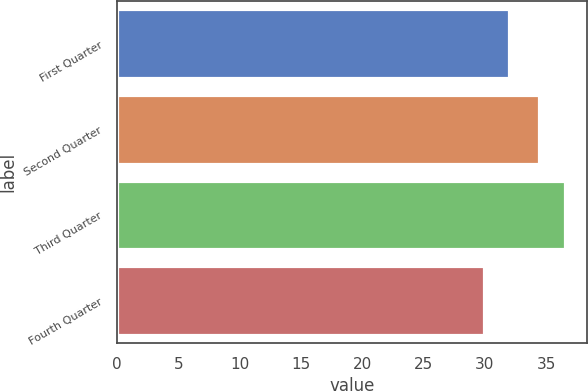<chart> <loc_0><loc_0><loc_500><loc_500><bar_chart><fcel>First Quarter<fcel>Second Quarter<fcel>Third Quarter<fcel>Fourth Quarter<nl><fcel>32<fcel>34.44<fcel>36.52<fcel>29.96<nl></chart> 